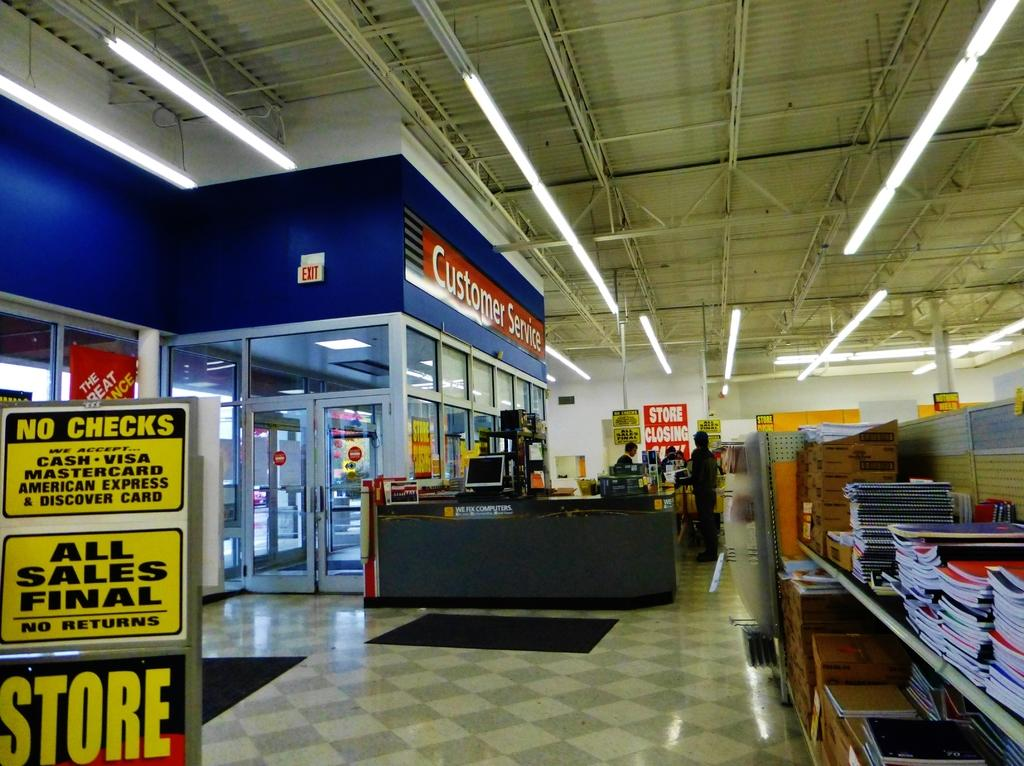<image>
Render a clear and concise summary of the photo. Store that contains books and customer service that do not accept checks 